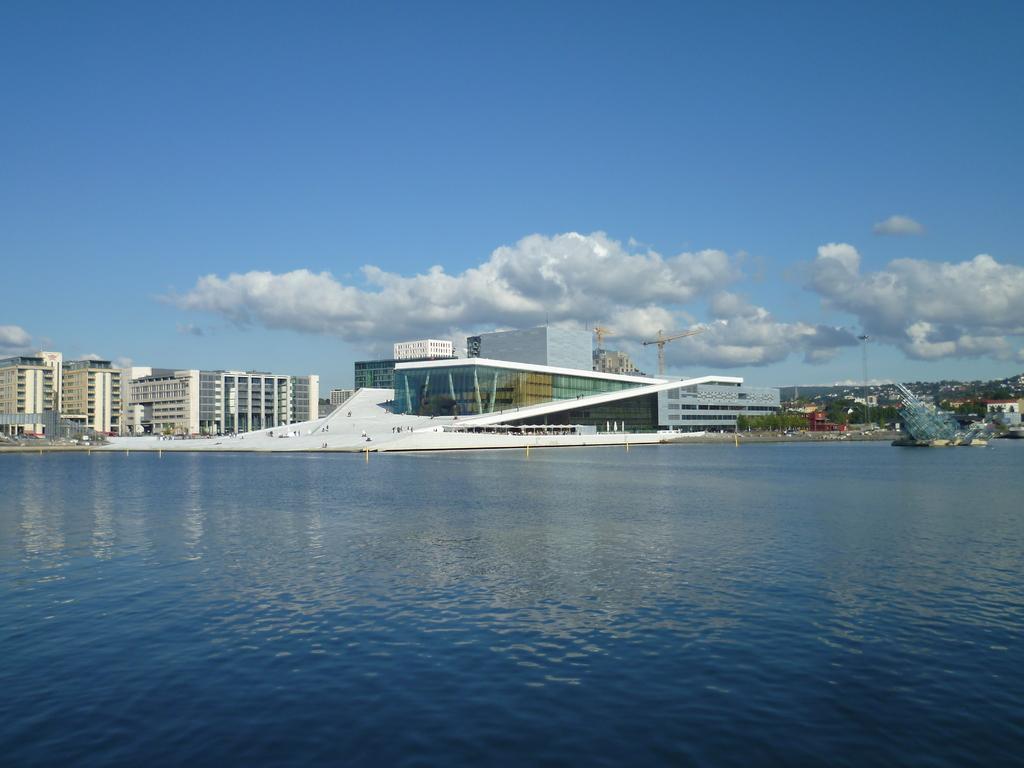Describe this image in one or two sentences. In this image at the bottom there is a beach, and in the center there are some buildings and some towers and at the top of the image there is sky. 